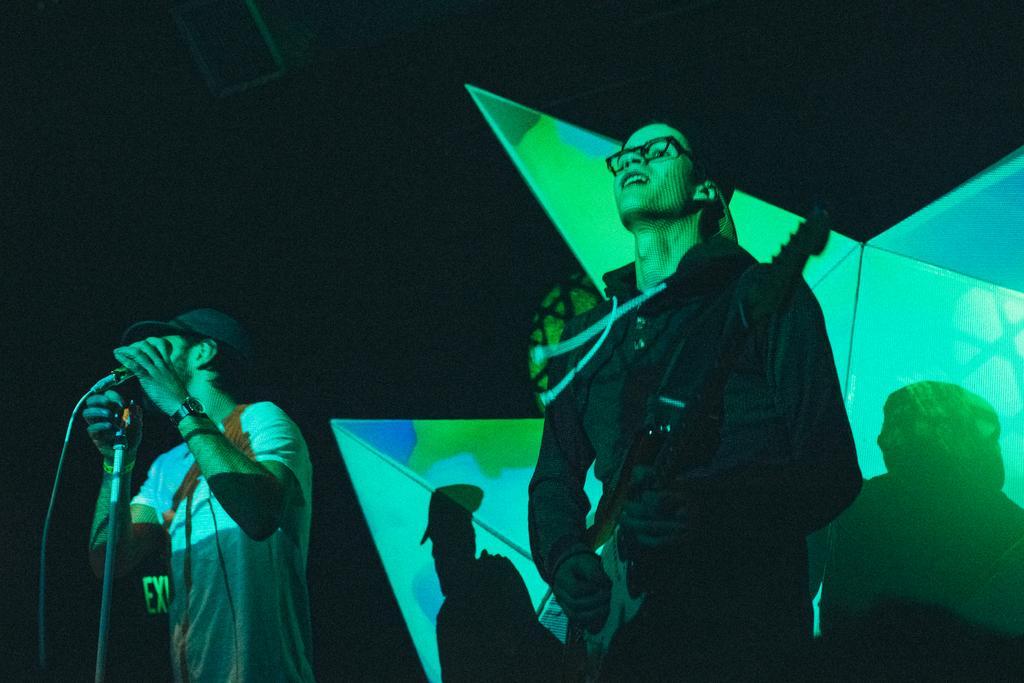Describe this image in one or two sentences. In this image, on the right side, we can see a man standing and holding a guitar in his hand. On the left side, we can also see another man standing and holding a microphone in his hand. In the background, we can see a light and shadows of two men. In the background, we can also see black color. 